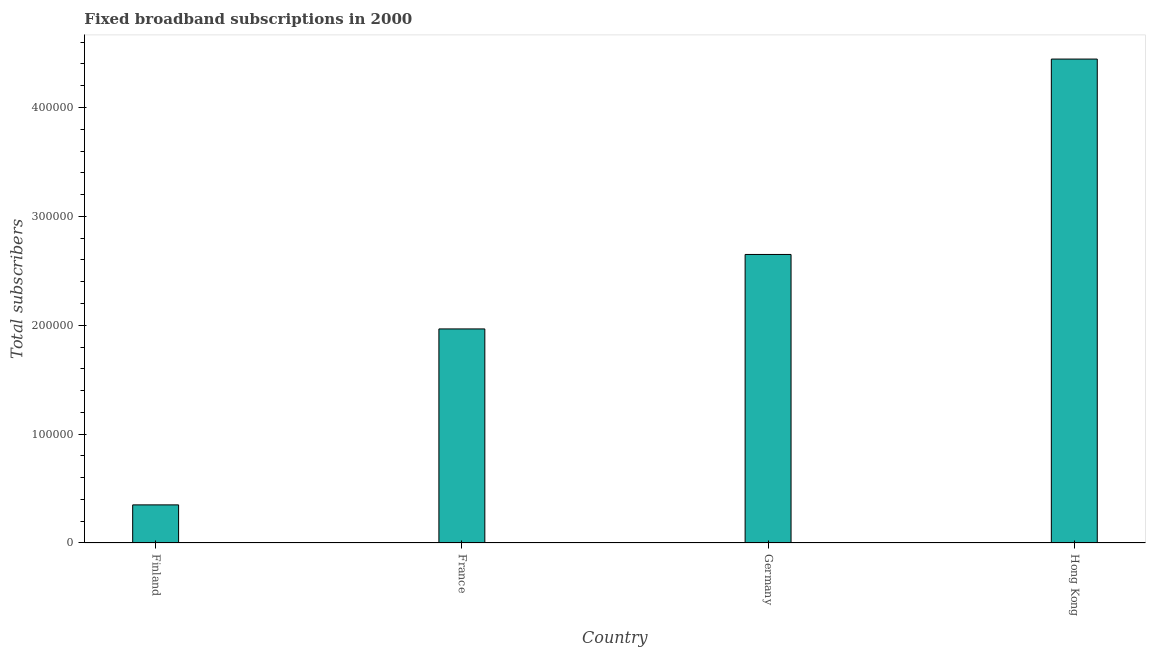Does the graph contain grids?
Make the answer very short. No. What is the title of the graph?
Keep it short and to the point. Fixed broadband subscriptions in 2000. What is the label or title of the X-axis?
Offer a terse response. Country. What is the label or title of the Y-axis?
Make the answer very short. Total subscribers. What is the total number of fixed broadband subscriptions in Finland?
Give a very brief answer. 3.50e+04. Across all countries, what is the maximum total number of fixed broadband subscriptions?
Ensure brevity in your answer.  4.44e+05. Across all countries, what is the minimum total number of fixed broadband subscriptions?
Keep it short and to the point. 3.50e+04. In which country was the total number of fixed broadband subscriptions maximum?
Make the answer very short. Hong Kong. In which country was the total number of fixed broadband subscriptions minimum?
Your response must be concise. Finland. What is the sum of the total number of fixed broadband subscriptions?
Make the answer very short. 9.41e+05. What is the difference between the total number of fixed broadband subscriptions in Germany and Hong Kong?
Ensure brevity in your answer.  -1.79e+05. What is the average total number of fixed broadband subscriptions per country?
Your answer should be compact. 2.35e+05. What is the median total number of fixed broadband subscriptions?
Your response must be concise. 2.31e+05. What is the ratio of the total number of fixed broadband subscriptions in Finland to that in Germany?
Offer a terse response. 0.13. Is the difference between the total number of fixed broadband subscriptions in Germany and Hong Kong greater than the difference between any two countries?
Your answer should be compact. No. What is the difference between the highest and the second highest total number of fixed broadband subscriptions?
Provide a short and direct response. 1.79e+05. Is the sum of the total number of fixed broadband subscriptions in Germany and Hong Kong greater than the maximum total number of fixed broadband subscriptions across all countries?
Keep it short and to the point. Yes. What is the difference between the highest and the lowest total number of fixed broadband subscriptions?
Offer a terse response. 4.09e+05. In how many countries, is the total number of fixed broadband subscriptions greater than the average total number of fixed broadband subscriptions taken over all countries?
Your response must be concise. 2. How many bars are there?
Make the answer very short. 4. Are all the bars in the graph horizontal?
Offer a very short reply. No. Are the values on the major ticks of Y-axis written in scientific E-notation?
Give a very brief answer. No. What is the Total subscribers of Finland?
Your answer should be compact. 3.50e+04. What is the Total subscribers in France?
Keep it short and to the point. 1.97e+05. What is the Total subscribers in Germany?
Ensure brevity in your answer.  2.65e+05. What is the Total subscribers of Hong Kong?
Your answer should be compact. 4.44e+05. What is the difference between the Total subscribers in Finland and France?
Give a very brief answer. -1.62e+05. What is the difference between the Total subscribers in Finland and Hong Kong?
Your response must be concise. -4.09e+05. What is the difference between the Total subscribers in France and Germany?
Offer a very short reply. -6.84e+04. What is the difference between the Total subscribers in France and Hong Kong?
Ensure brevity in your answer.  -2.48e+05. What is the difference between the Total subscribers in Germany and Hong Kong?
Offer a terse response. -1.79e+05. What is the ratio of the Total subscribers in Finland to that in France?
Ensure brevity in your answer.  0.18. What is the ratio of the Total subscribers in Finland to that in Germany?
Keep it short and to the point. 0.13. What is the ratio of the Total subscribers in Finland to that in Hong Kong?
Make the answer very short. 0.08. What is the ratio of the Total subscribers in France to that in Germany?
Your answer should be compact. 0.74. What is the ratio of the Total subscribers in France to that in Hong Kong?
Keep it short and to the point. 0.44. What is the ratio of the Total subscribers in Germany to that in Hong Kong?
Ensure brevity in your answer.  0.6. 